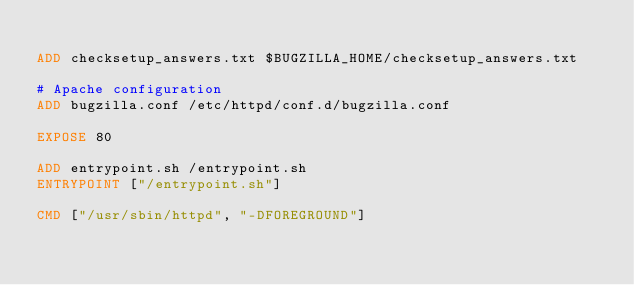Convert code to text. <code><loc_0><loc_0><loc_500><loc_500><_Dockerfile_>
ADD checksetup_answers.txt $BUGZILLA_HOME/checksetup_answers.txt

# Apache configuration
ADD bugzilla.conf /etc/httpd/conf.d/bugzilla.conf

EXPOSE 80

ADD entrypoint.sh /entrypoint.sh
ENTRYPOINT ["/entrypoint.sh"]

CMD ["/usr/sbin/httpd", "-DFOREGROUND"]
</code> 